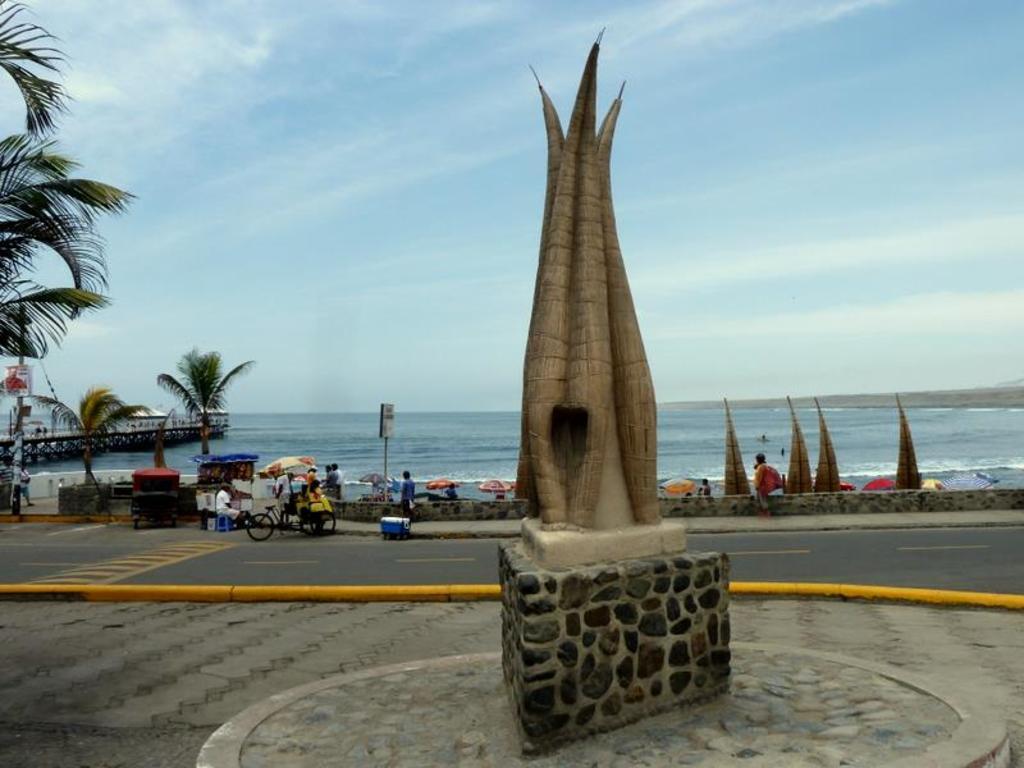In one or two sentences, can you explain what this image depicts? In this image there is an architecture in the middle. In the background there is a beach. At the top there is the sky. Behind the architecture there is a road at the bottom. Beside the road there are so many shops which are kept under the umbrellas. In the background there is water. On the right side there are few umbrellas. On the left side there are trees. 